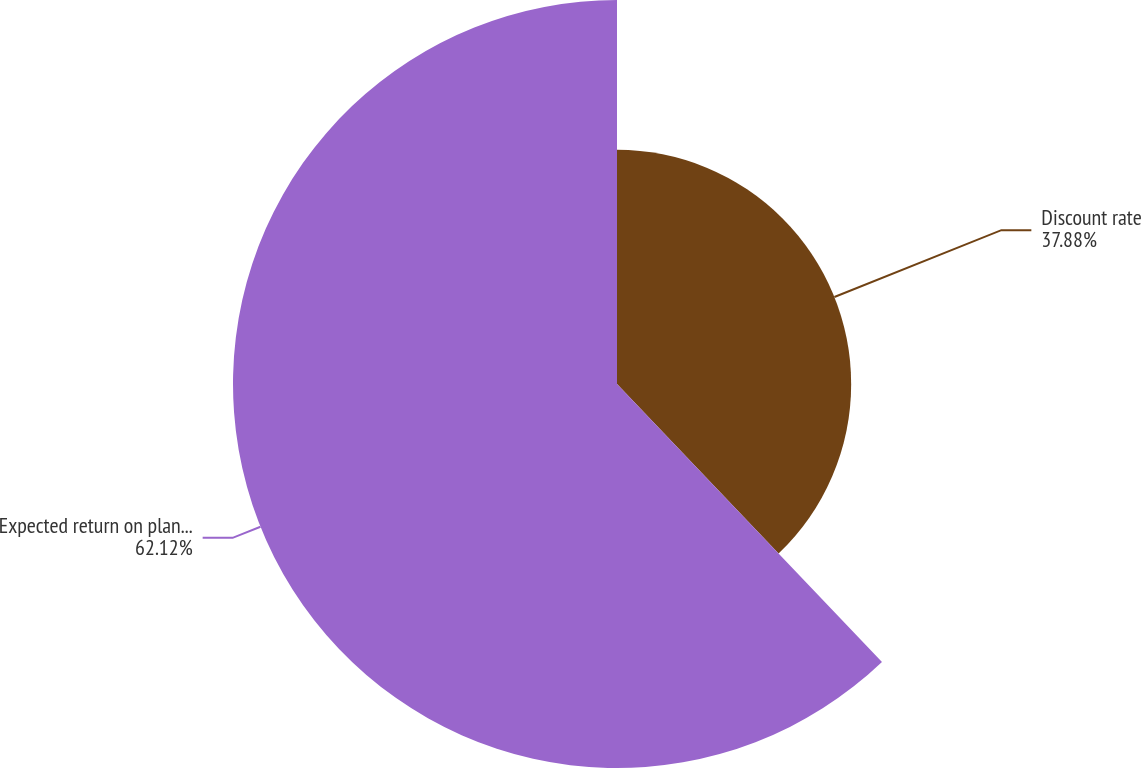Convert chart. <chart><loc_0><loc_0><loc_500><loc_500><pie_chart><fcel>Discount rate<fcel>Expected return on plan assets<nl><fcel>37.88%<fcel>62.12%<nl></chart> 